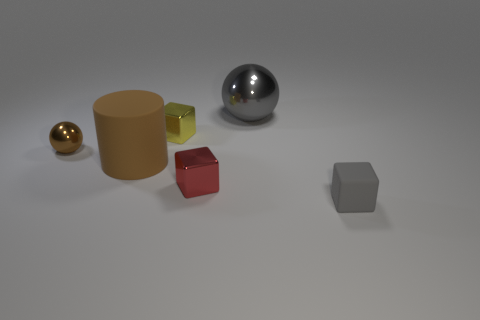What material is the ball that is the same color as the matte cylinder? The ball that shares the same golden color as the matte cylinder appears to be made of a polished metal, reflecting light and surroundings with a smooth, mirror-like finish. 